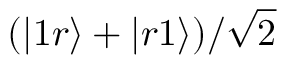<formula> <loc_0><loc_0><loc_500><loc_500>( | 1 r \rangle + | r 1 \rangle ) / \sqrt { 2 }</formula> 